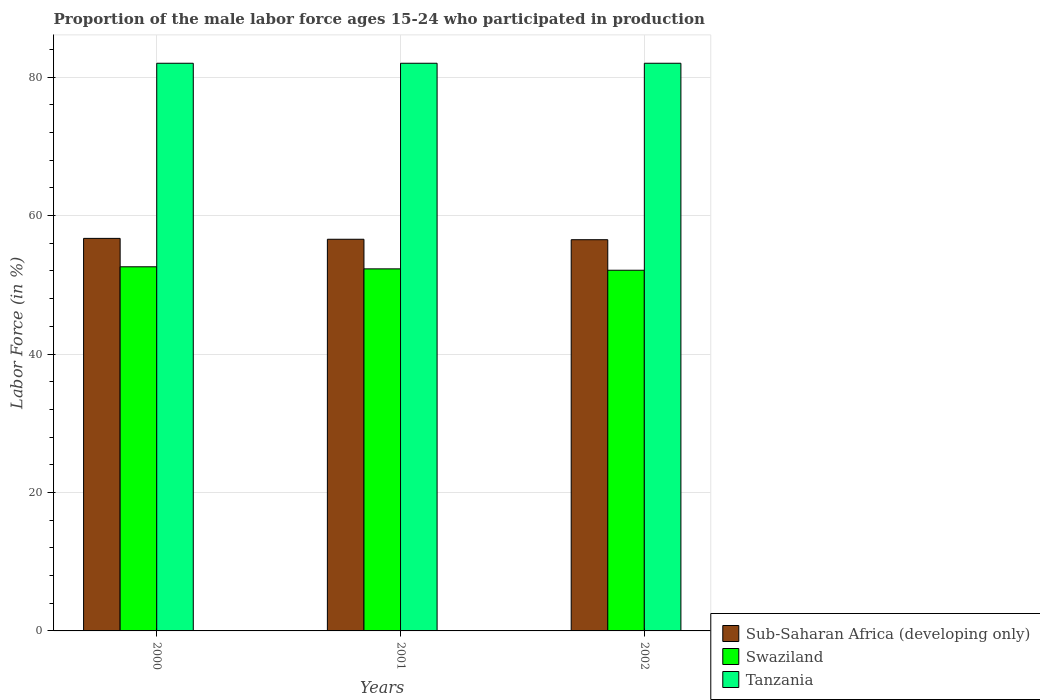Are the number of bars per tick equal to the number of legend labels?
Your answer should be very brief. Yes. Are the number of bars on each tick of the X-axis equal?
Your response must be concise. Yes. In how many cases, is the number of bars for a given year not equal to the number of legend labels?
Provide a short and direct response. 0. What is the proportion of the male labor force who participated in production in Tanzania in 2000?
Ensure brevity in your answer.  82. Across all years, what is the maximum proportion of the male labor force who participated in production in Sub-Saharan Africa (developing only)?
Ensure brevity in your answer.  56.7. Across all years, what is the minimum proportion of the male labor force who participated in production in Sub-Saharan Africa (developing only)?
Offer a very short reply. 56.51. In which year was the proportion of the male labor force who participated in production in Sub-Saharan Africa (developing only) maximum?
Keep it short and to the point. 2000. What is the total proportion of the male labor force who participated in production in Sub-Saharan Africa (developing only) in the graph?
Ensure brevity in your answer.  169.79. What is the difference between the proportion of the male labor force who participated in production in Tanzania in 2000 and that in 2001?
Provide a short and direct response. 0. What is the difference between the proportion of the male labor force who participated in production in Swaziland in 2000 and the proportion of the male labor force who participated in production in Tanzania in 2002?
Provide a short and direct response. -29.4. What is the average proportion of the male labor force who participated in production in Swaziland per year?
Provide a short and direct response. 52.33. In the year 2000, what is the difference between the proportion of the male labor force who participated in production in Tanzania and proportion of the male labor force who participated in production in Sub-Saharan Africa (developing only)?
Your response must be concise. 25.3. In how many years, is the proportion of the male labor force who participated in production in Tanzania greater than 76 %?
Your answer should be very brief. 3. What is the difference between the highest and the lowest proportion of the male labor force who participated in production in Sub-Saharan Africa (developing only)?
Your answer should be very brief. 0.19. Is the sum of the proportion of the male labor force who participated in production in Swaziland in 2000 and 2002 greater than the maximum proportion of the male labor force who participated in production in Tanzania across all years?
Offer a terse response. Yes. What does the 3rd bar from the left in 2000 represents?
Your answer should be very brief. Tanzania. What does the 3rd bar from the right in 2002 represents?
Your response must be concise. Sub-Saharan Africa (developing only). Is it the case that in every year, the sum of the proportion of the male labor force who participated in production in Sub-Saharan Africa (developing only) and proportion of the male labor force who participated in production in Tanzania is greater than the proportion of the male labor force who participated in production in Swaziland?
Make the answer very short. Yes. How many years are there in the graph?
Give a very brief answer. 3. What is the difference between two consecutive major ticks on the Y-axis?
Your answer should be very brief. 20. Does the graph contain grids?
Keep it short and to the point. Yes. How are the legend labels stacked?
Your answer should be very brief. Vertical. What is the title of the graph?
Your response must be concise. Proportion of the male labor force ages 15-24 who participated in production. Does "Ukraine" appear as one of the legend labels in the graph?
Provide a succinct answer. No. What is the label or title of the X-axis?
Your response must be concise. Years. What is the Labor Force (in %) of Sub-Saharan Africa (developing only) in 2000?
Make the answer very short. 56.7. What is the Labor Force (in %) in Swaziland in 2000?
Offer a very short reply. 52.6. What is the Labor Force (in %) of Sub-Saharan Africa (developing only) in 2001?
Provide a succinct answer. 56.58. What is the Labor Force (in %) of Swaziland in 2001?
Make the answer very short. 52.3. What is the Labor Force (in %) of Sub-Saharan Africa (developing only) in 2002?
Provide a short and direct response. 56.51. What is the Labor Force (in %) in Swaziland in 2002?
Offer a terse response. 52.1. Across all years, what is the maximum Labor Force (in %) in Sub-Saharan Africa (developing only)?
Keep it short and to the point. 56.7. Across all years, what is the maximum Labor Force (in %) in Swaziland?
Offer a very short reply. 52.6. Across all years, what is the minimum Labor Force (in %) in Sub-Saharan Africa (developing only)?
Ensure brevity in your answer.  56.51. Across all years, what is the minimum Labor Force (in %) in Swaziland?
Offer a very short reply. 52.1. What is the total Labor Force (in %) in Sub-Saharan Africa (developing only) in the graph?
Ensure brevity in your answer.  169.79. What is the total Labor Force (in %) in Swaziland in the graph?
Provide a succinct answer. 157. What is the total Labor Force (in %) in Tanzania in the graph?
Provide a short and direct response. 246. What is the difference between the Labor Force (in %) in Sub-Saharan Africa (developing only) in 2000 and that in 2001?
Provide a succinct answer. 0.13. What is the difference between the Labor Force (in %) in Swaziland in 2000 and that in 2001?
Give a very brief answer. 0.3. What is the difference between the Labor Force (in %) in Tanzania in 2000 and that in 2001?
Ensure brevity in your answer.  0. What is the difference between the Labor Force (in %) in Sub-Saharan Africa (developing only) in 2000 and that in 2002?
Your response must be concise. 0.19. What is the difference between the Labor Force (in %) in Sub-Saharan Africa (developing only) in 2001 and that in 2002?
Provide a short and direct response. 0.07. What is the difference between the Labor Force (in %) of Swaziland in 2001 and that in 2002?
Your answer should be very brief. 0.2. What is the difference between the Labor Force (in %) of Tanzania in 2001 and that in 2002?
Your answer should be compact. 0. What is the difference between the Labor Force (in %) in Sub-Saharan Africa (developing only) in 2000 and the Labor Force (in %) in Swaziland in 2001?
Give a very brief answer. 4.4. What is the difference between the Labor Force (in %) in Sub-Saharan Africa (developing only) in 2000 and the Labor Force (in %) in Tanzania in 2001?
Provide a succinct answer. -25.3. What is the difference between the Labor Force (in %) of Swaziland in 2000 and the Labor Force (in %) of Tanzania in 2001?
Your answer should be compact. -29.4. What is the difference between the Labor Force (in %) in Sub-Saharan Africa (developing only) in 2000 and the Labor Force (in %) in Swaziland in 2002?
Your response must be concise. 4.6. What is the difference between the Labor Force (in %) in Sub-Saharan Africa (developing only) in 2000 and the Labor Force (in %) in Tanzania in 2002?
Provide a short and direct response. -25.3. What is the difference between the Labor Force (in %) in Swaziland in 2000 and the Labor Force (in %) in Tanzania in 2002?
Your answer should be compact. -29.4. What is the difference between the Labor Force (in %) in Sub-Saharan Africa (developing only) in 2001 and the Labor Force (in %) in Swaziland in 2002?
Provide a succinct answer. 4.48. What is the difference between the Labor Force (in %) of Sub-Saharan Africa (developing only) in 2001 and the Labor Force (in %) of Tanzania in 2002?
Give a very brief answer. -25.42. What is the difference between the Labor Force (in %) of Swaziland in 2001 and the Labor Force (in %) of Tanzania in 2002?
Offer a terse response. -29.7. What is the average Labor Force (in %) in Sub-Saharan Africa (developing only) per year?
Give a very brief answer. 56.6. What is the average Labor Force (in %) in Swaziland per year?
Give a very brief answer. 52.33. What is the average Labor Force (in %) of Tanzania per year?
Keep it short and to the point. 82. In the year 2000, what is the difference between the Labor Force (in %) of Sub-Saharan Africa (developing only) and Labor Force (in %) of Swaziland?
Provide a short and direct response. 4.1. In the year 2000, what is the difference between the Labor Force (in %) in Sub-Saharan Africa (developing only) and Labor Force (in %) in Tanzania?
Provide a succinct answer. -25.3. In the year 2000, what is the difference between the Labor Force (in %) of Swaziland and Labor Force (in %) of Tanzania?
Offer a very short reply. -29.4. In the year 2001, what is the difference between the Labor Force (in %) of Sub-Saharan Africa (developing only) and Labor Force (in %) of Swaziland?
Make the answer very short. 4.28. In the year 2001, what is the difference between the Labor Force (in %) of Sub-Saharan Africa (developing only) and Labor Force (in %) of Tanzania?
Your response must be concise. -25.42. In the year 2001, what is the difference between the Labor Force (in %) of Swaziland and Labor Force (in %) of Tanzania?
Your answer should be compact. -29.7. In the year 2002, what is the difference between the Labor Force (in %) in Sub-Saharan Africa (developing only) and Labor Force (in %) in Swaziland?
Your answer should be very brief. 4.41. In the year 2002, what is the difference between the Labor Force (in %) of Sub-Saharan Africa (developing only) and Labor Force (in %) of Tanzania?
Keep it short and to the point. -25.49. In the year 2002, what is the difference between the Labor Force (in %) of Swaziland and Labor Force (in %) of Tanzania?
Your answer should be compact. -29.9. What is the ratio of the Labor Force (in %) in Swaziland in 2000 to that in 2001?
Offer a terse response. 1.01. What is the ratio of the Labor Force (in %) in Tanzania in 2000 to that in 2001?
Ensure brevity in your answer.  1. What is the ratio of the Labor Force (in %) in Swaziland in 2000 to that in 2002?
Your answer should be very brief. 1.01. What is the ratio of the Labor Force (in %) of Tanzania in 2000 to that in 2002?
Keep it short and to the point. 1. What is the difference between the highest and the second highest Labor Force (in %) in Sub-Saharan Africa (developing only)?
Give a very brief answer. 0.13. What is the difference between the highest and the lowest Labor Force (in %) of Sub-Saharan Africa (developing only)?
Offer a very short reply. 0.19. What is the difference between the highest and the lowest Labor Force (in %) in Swaziland?
Your answer should be very brief. 0.5. What is the difference between the highest and the lowest Labor Force (in %) in Tanzania?
Provide a succinct answer. 0. 